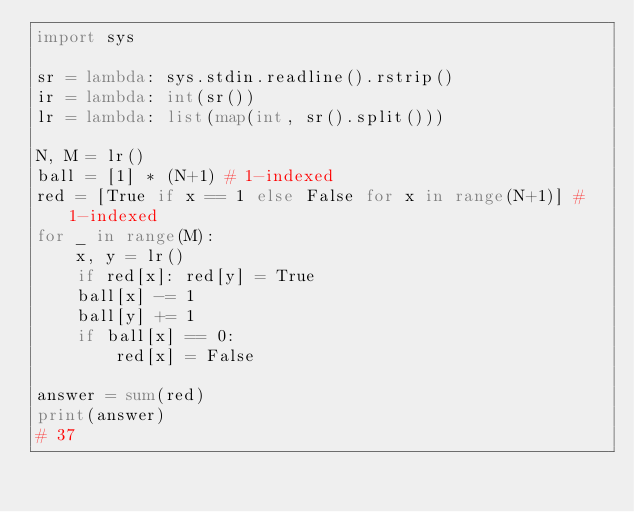<code> <loc_0><loc_0><loc_500><loc_500><_Python_>import sys

sr = lambda: sys.stdin.readline().rstrip()
ir = lambda: int(sr())
lr = lambda: list(map(int, sr().split()))

N, M = lr()
ball = [1] * (N+1) # 1-indexed
red = [True if x == 1 else False for x in range(N+1)] # 1-indexed
for _ in range(M):
    x, y = lr()
    if red[x]: red[y] = True
    ball[x] -= 1
    ball[y] += 1
    if ball[x] == 0:
        red[x] = False

answer = sum(red)
print(answer)
# 37</code> 